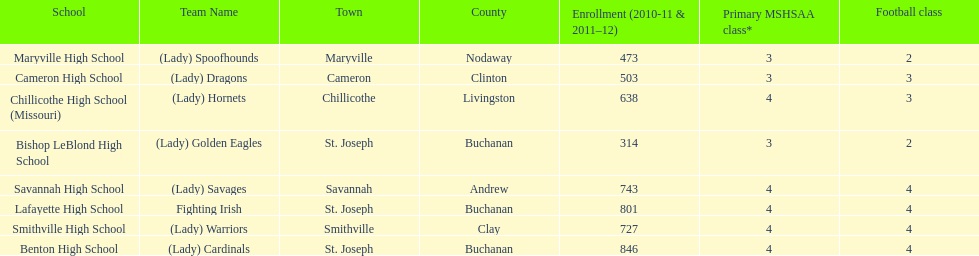What is the number of football classes lafayette high school has? 4. 